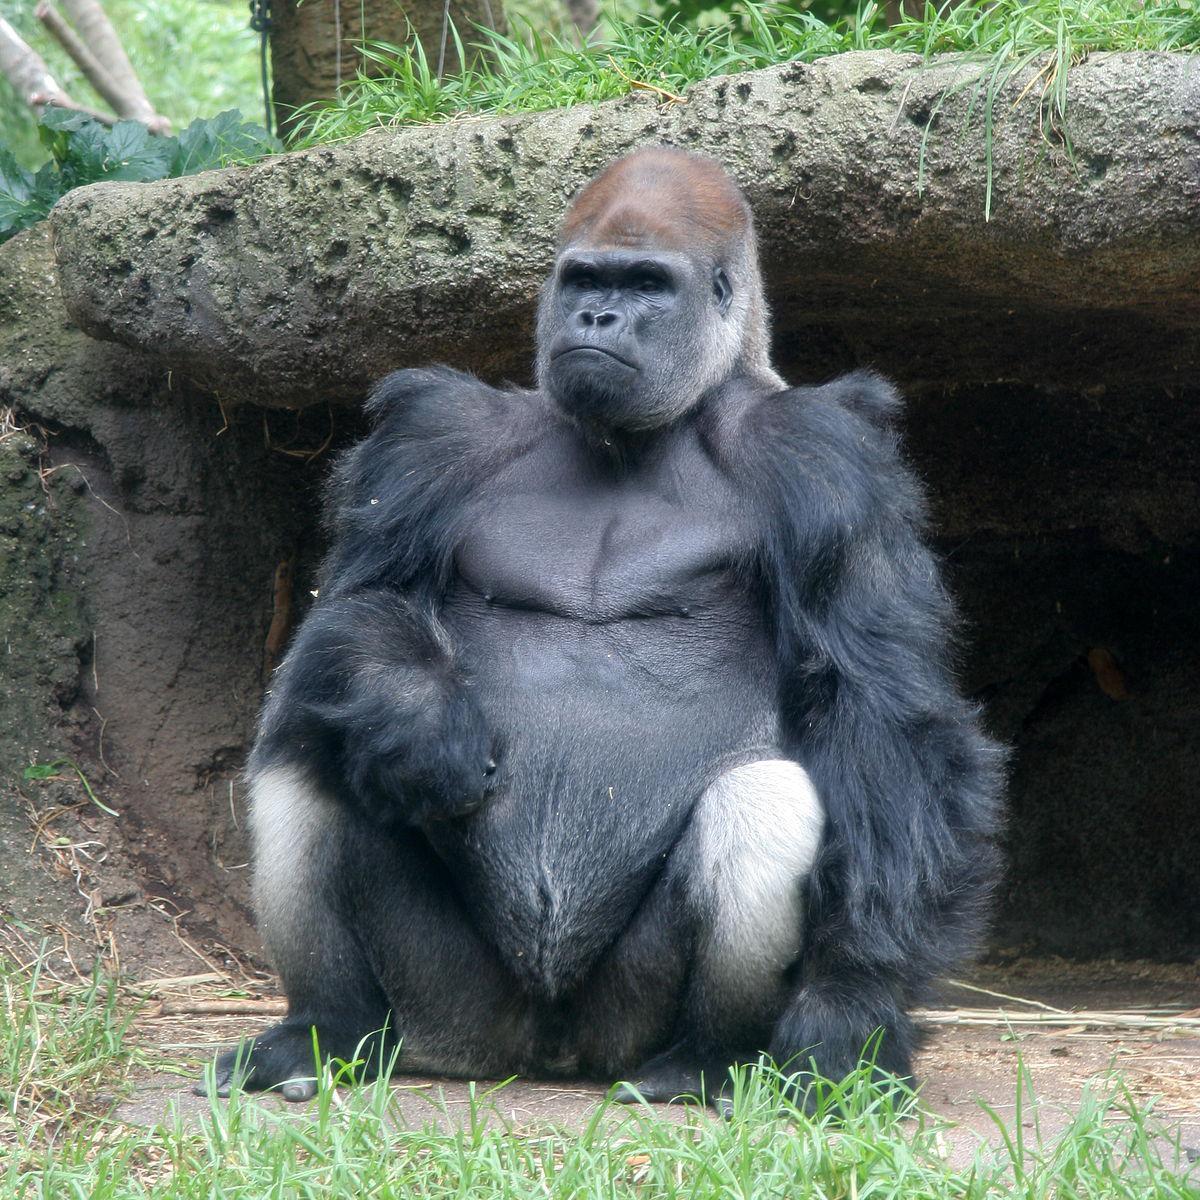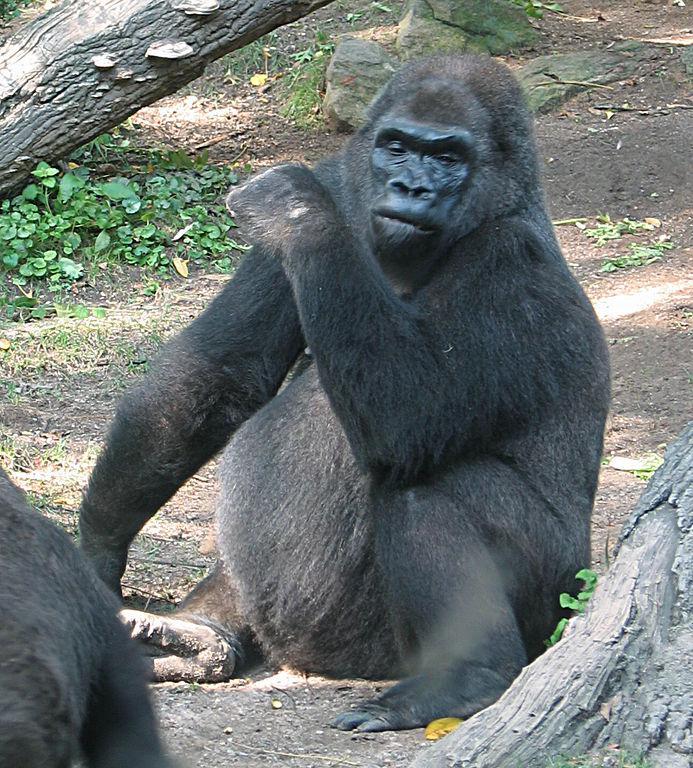The first image is the image on the left, the second image is the image on the right. Examine the images to the left and right. Is the description "Exactly one of the ape's feet can be seen in the image on the right." accurate? Answer yes or no. No. 